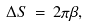Convert formula to latex. <formula><loc_0><loc_0><loc_500><loc_500>\Delta S \, = \, 2 \pi \beta ,</formula> 